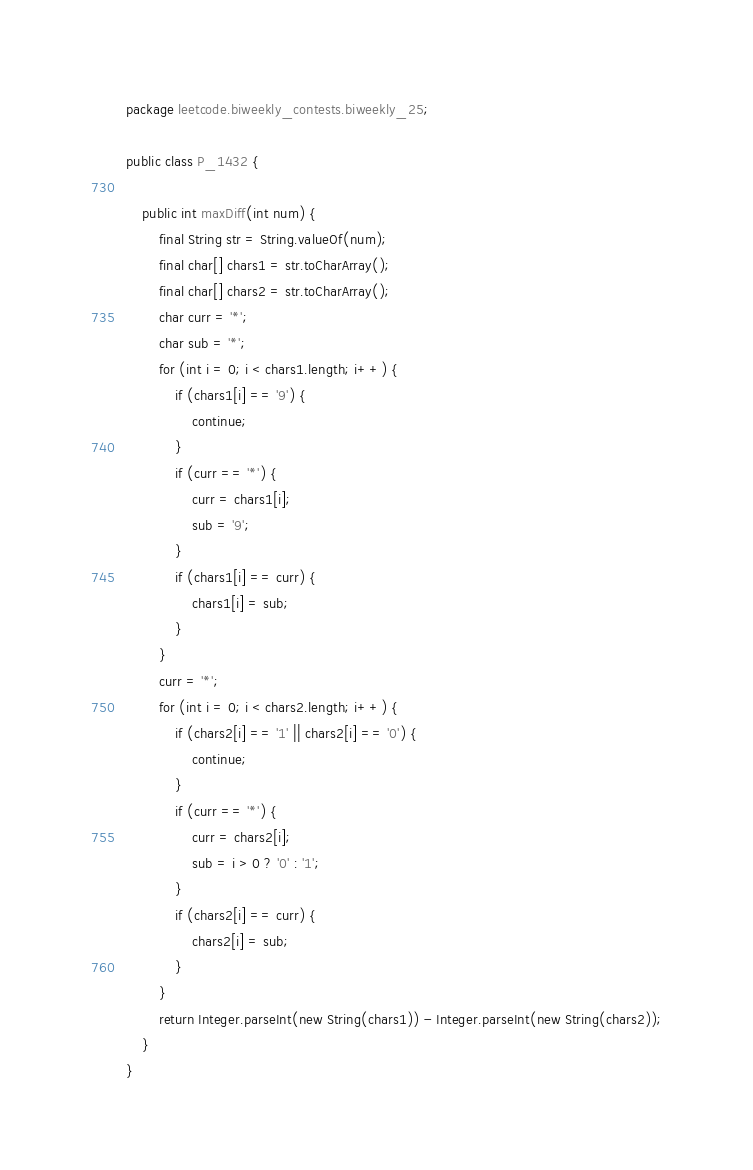Convert code to text. <code><loc_0><loc_0><loc_500><loc_500><_Java_>package leetcode.biweekly_contests.biweekly_25;

public class P_1432 {

    public int maxDiff(int num) {
        final String str = String.valueOf(num);
        final char[] chars1 = str.toCharArray();
        final char[] chars2 = str.toCharArray();
        char curr = '*';
        char sub = '*';
        for (int i = 0; i < chars1.length; i++) {
            if (chars1[i] == '9') {
                continue;
            }
            if (curr == '*') {
                curr = chars1[i];
                sub = '9';
            }
            if (chars1[i] == curr) {
                chars1[i] = sub;
            }
        }
        curr = '*';
        for (int i = 0; i < chars2.length; i++) {
            if (chars2[i] == '1' || chars2[i] == '0') {
                continue;
            }
            if (curr == '*') {
                curr = chars2[i];
                sub = i > 0 ? '0' : '1';
            }
            if (chars2[i] == curr) {
                chars2[i] = sub;
            }
        }
        return Integer.parseInt(new String(chars1)) - Integer.parseInt(new String(chars2));
    }
}
</code> 